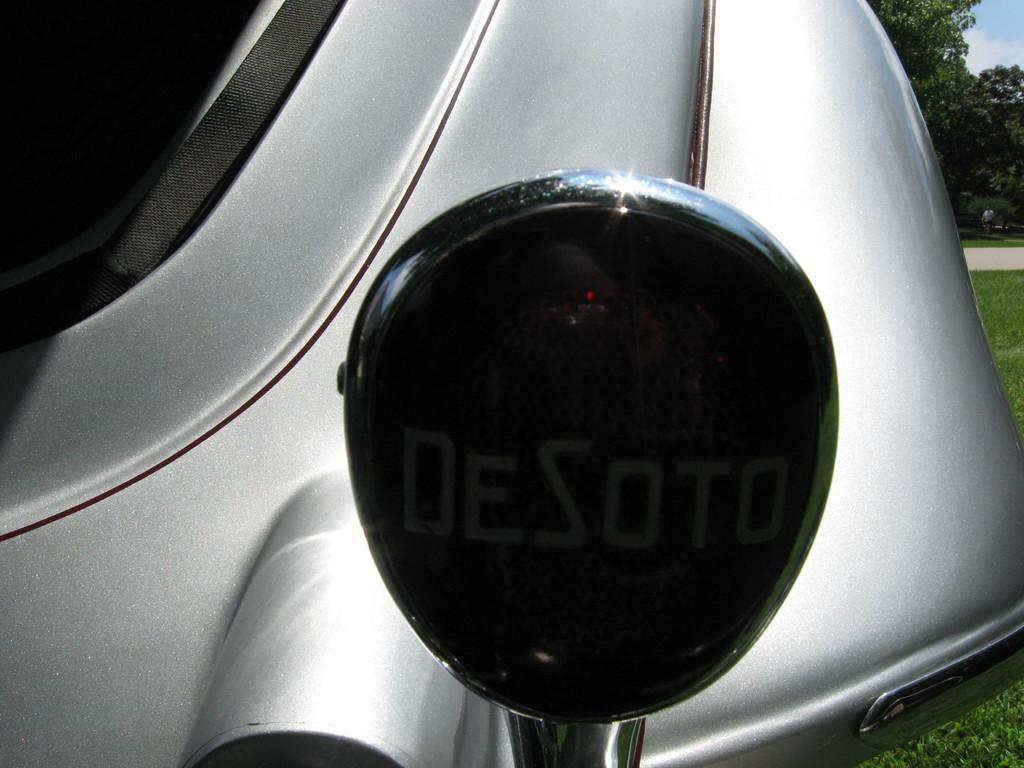Could you give a brief overview of what you see in this image? In this picture we can see car. Here can see a mirror. On the right background we can see many trees. On the bottom right corner we can see grass. On the top right corner we can see sky and clouds. 